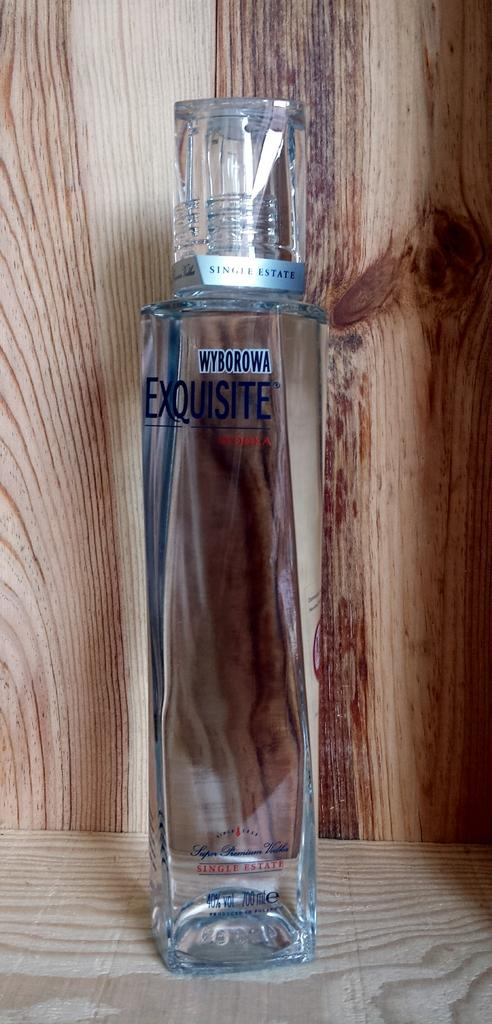<image>
Offer a succinct explanation of the picture presented. Sitting on the wooden shelf is a tall clear bottle of Wyborowa brand vodka. 